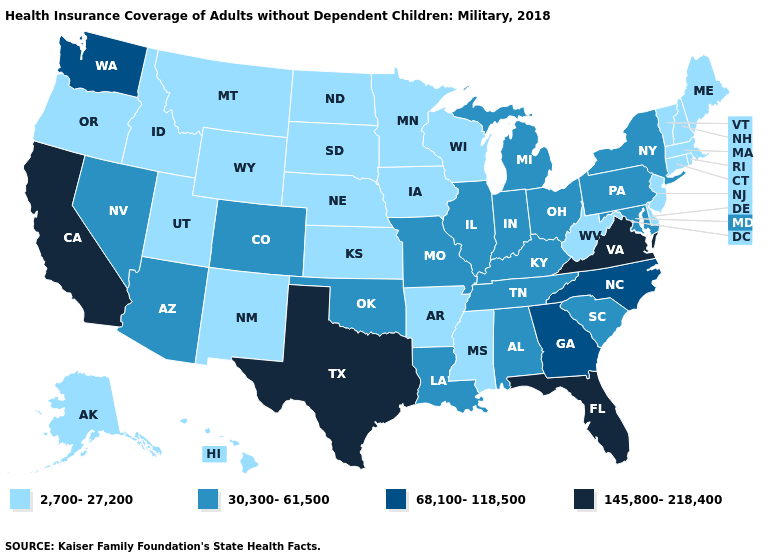Name the states that have a value in the range 2,700-27,200?
Be succinct. Alaska, Arkansas, Connecticut, Delaware, Hawaii, Idaho, Iowa, Kansas, Maine, Massachusetts, Minnesota, Mississippi, Montana, Nebraska, New Hampshire, New Jersey, New Mexico, North Dakota, Oregon, Rhode Island, South Dakota, Utah, Vermont, West Virginia, Wisconsin, Wyoming. Name the states that have a value in the range 2,700-27,200?
Answer briefly. Alaska, Arkansas, Connecticut, Delaware, Hawaii, Idaho, Iowa, Kansas, Maine, Massachusetts, Minnesota, Mississippi, Montana, Nebraska, New Hampshire, New Jersey, New Mexico, North Dakota, Oregon, Rhode Island, South Dakota, Utah, Vermont, West Virginia, Wisconsin, Wyoming. Is the legend a continuous bar?
Quick response, please. No. Name the states that have a value in the range 30,300-61,500?
Give a very brief answer. Alabama, Arizona, Colorado, Illinois, Indiana, Kentucky, Louisiana, Maryland, Michigan, Missouri, Nevada, New York, Ohio, Oklahoma, Pennsylvania, South Carolina, Tennessee. Which states have the lowest value in the Northeast?
Answer briefly. Connecticut, Maine, Massachusetts, New Hampshire, New Jersey, Rhode Island, Vermont. Does the first symbol in the legend represent the smallest category?
Quick response, please. Yes. Which states have the lowest value in the USA?
Concise answer only. Alaska, Arkansas, Connecticut, Delaware, Hawaii, Idaho, Iowa, Kansas, Maine, Massachusetts, Minnesota, Mississippi, Montana, Nebraska, New Hampshire, New Jersey, New Mexico, North Dakota, Oregon, Rhode Island, South Dakota, Utah, Vermont, West Virginia, Wisconsin, Wyoming. Name the states that have a value in the range 68,100-118,500?
Concise answer only. Georgia, North Carolina, Washington. Among the states that border Colorado , which have the highest value?
Short answer required. Arizona, Oklahoma. Among the states that border New Jersey , which have the highest value?
Write a very short answer. New York, Pennsylvania. What is the highest value in states that border Kentucky?
Write a very short answer. 145,800-218,400. How many symbols are there in the legend?
Answer briefly. 4. What is the highest value in states that border California?
Quick response, please. 30,300-61,500. Which states hav the highest value in the West?
Short answer required. California. Does South Carolina have a higher value than South Dakota?
Concise answer only. Yes. 